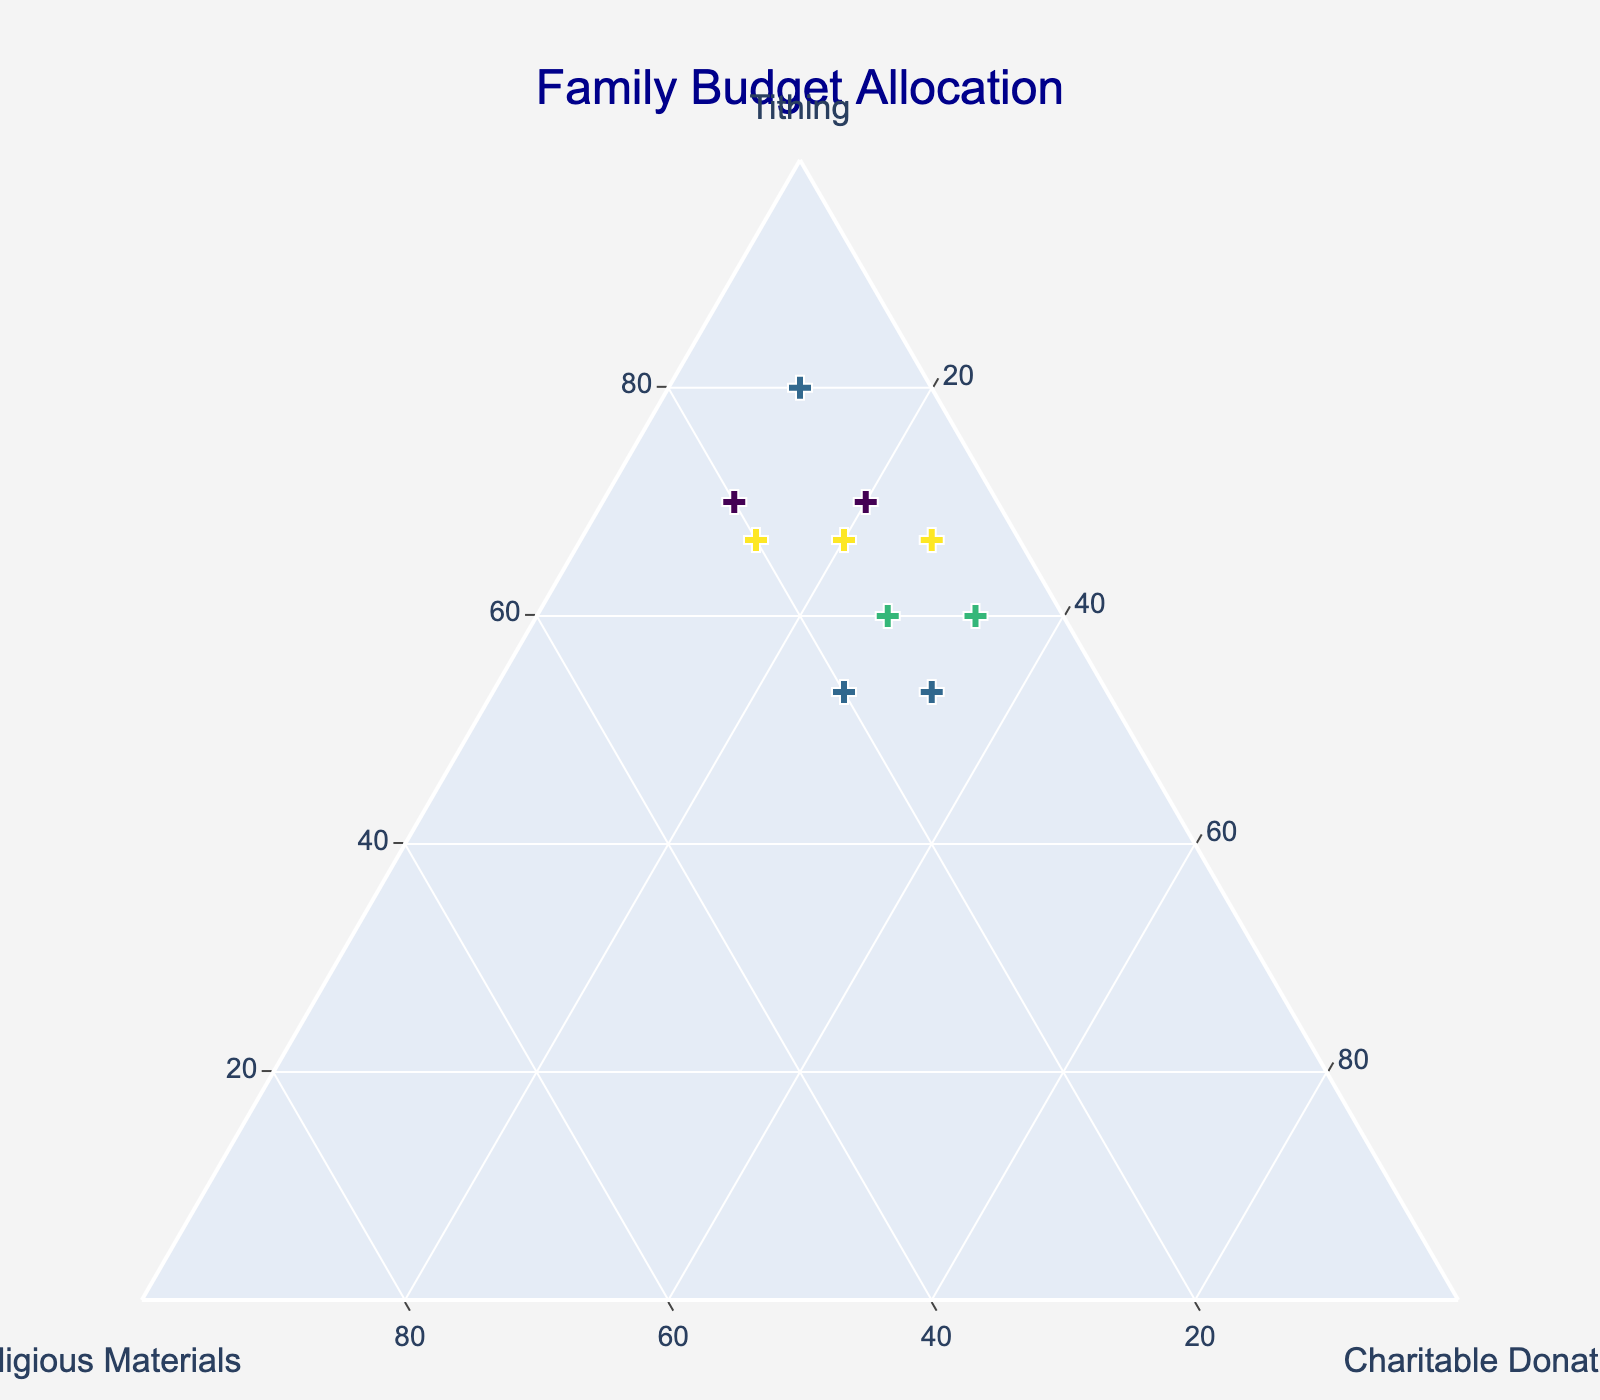What's the title of the figure? The title is usually located at the top of the figure. In this case, the title is prominently displayed in the center.
Answer: Family Budget Allocation How many data points are plotted? Each cross represents a data point. Counting each cross will give the total number of data points.
Answer: 10 What is the represented budget allocation for the point with the highest tithing value? We need to look for the data point with the largest value on the 'a' axis, which represents tithing, and check the corresponding values for religious materials and charitable donations.
Answer: Tithing: 10, Religious Materials: 2, Charitable Donations: 3 Which data point has the smallest allocation for charitable donations? Look at the 'c' axis for the smallest value and check the corresponding values for tithing and religious materials.
Answer: Tithing: 8, Religious Materials: 1, Charitable Donations: 1 What is the sum of allocations for tithing and charitable donations for the data point with tithing value of 8? Find the points with tithing value of 8 and sum the values of tithing and charitable donations for these points.
Answer: 12 What is the average value of religious materials allocations across all data points? Sum all the values for religious materials and then divide by the number of data points. The values are (2+3+1+2+1+3+1+2+2+1). The average is (2+3+1+2+1+3+1+2+2+1)/10.
Answer: 1.8 Which point has an equal allocation for tithing and charitable donations? Check all points and compare the values for tithing and charitable donations to find any that are equal.
Answer: Tithing: 7, Religious Materials: 1, Charitable Donations: 7 Which data point has the same allocation for tithing and religious materials? Identify any points where the values for tithing and religious materials are equal.
Answer: None 